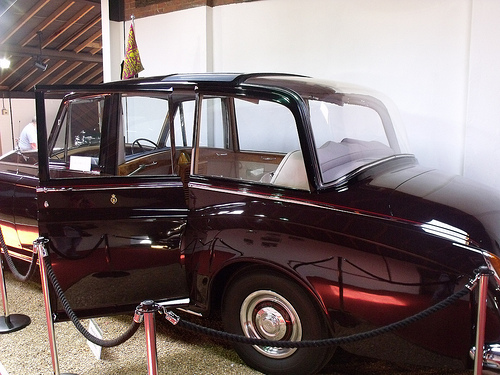<image>
Can you confirm if the car is in front of the fence? No. The car is not in front of the fence. The spatial positioning shows a different relationship between these objects. 